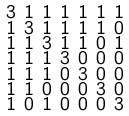Convert formula to latex. <formula><loc_0><loc_0><loc_500><loc_500>\begin{smallmatrix} 3 & 1 & 1 & 1 & 1 & 1 & 1 \\ 1 & 3 & 1 & 1 & 1 & 1 & 0 \\ 1 & 1 & 3 & 1 & 1 & 0 & 1 \\ 1 & 1 & 1 & 3 & 0 & 0 & 0 \\ 1 & 1 & 1 & 0 & 3 & 0 & 0 \\ 1 & 1 & 0 & 0 & 0 & 3 & 0 \\ 1 & 0 & 1 & 0 & 0 & 0 & 3 \end{smallmatrix}</formula> 